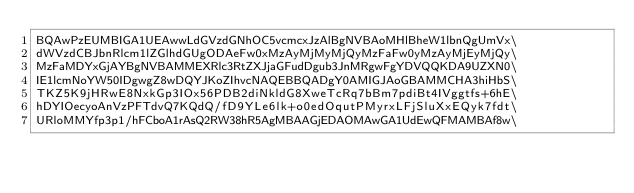Convert code to text. <code><loc_0><loc_0><loc_500><loc_500><_C_>BQAwPzEUMBIGA1UEAwwLdGVzdGNhOC5vcmcxJzAlBgNVBAoMHlBheW1lbnQgUmVx\
dWVzdCBJbnRlcm1lZGlhdGUgODAeFw0xMzAyMjMyMjQyMzFaFw0yMzAyMjEyMjQy\
MzFaMDYxGjAYBgNVBAMMEXRlc3RtZXJjaGFudDgub3JnMRgwFgYDVQQKDA9UZXN0\
IE1lcmNoYW50IDgwgZ8wDQYJKoZIhvcNAQEBBQADgY0AMIGJAoGBAMMCHA3hiHbS\
TKZ5K9jHRwE8NxkGp3IOx56PDB2diNkldG8XweTcRq7bBm7pdiBt4IVggtfs+6hE\
hDYIOecyoAnVzPFTdvQ7KQdQ/fD9YLe6lk+o0edOqutPMyrxLFjSluXxEQyk7fdt\
URloMMYfp3p1/hFCboA1rAsQ2RW38hR5AgMBAAGjEDAOMAwGA1UdEwQFMAMBAf8w\</code> 